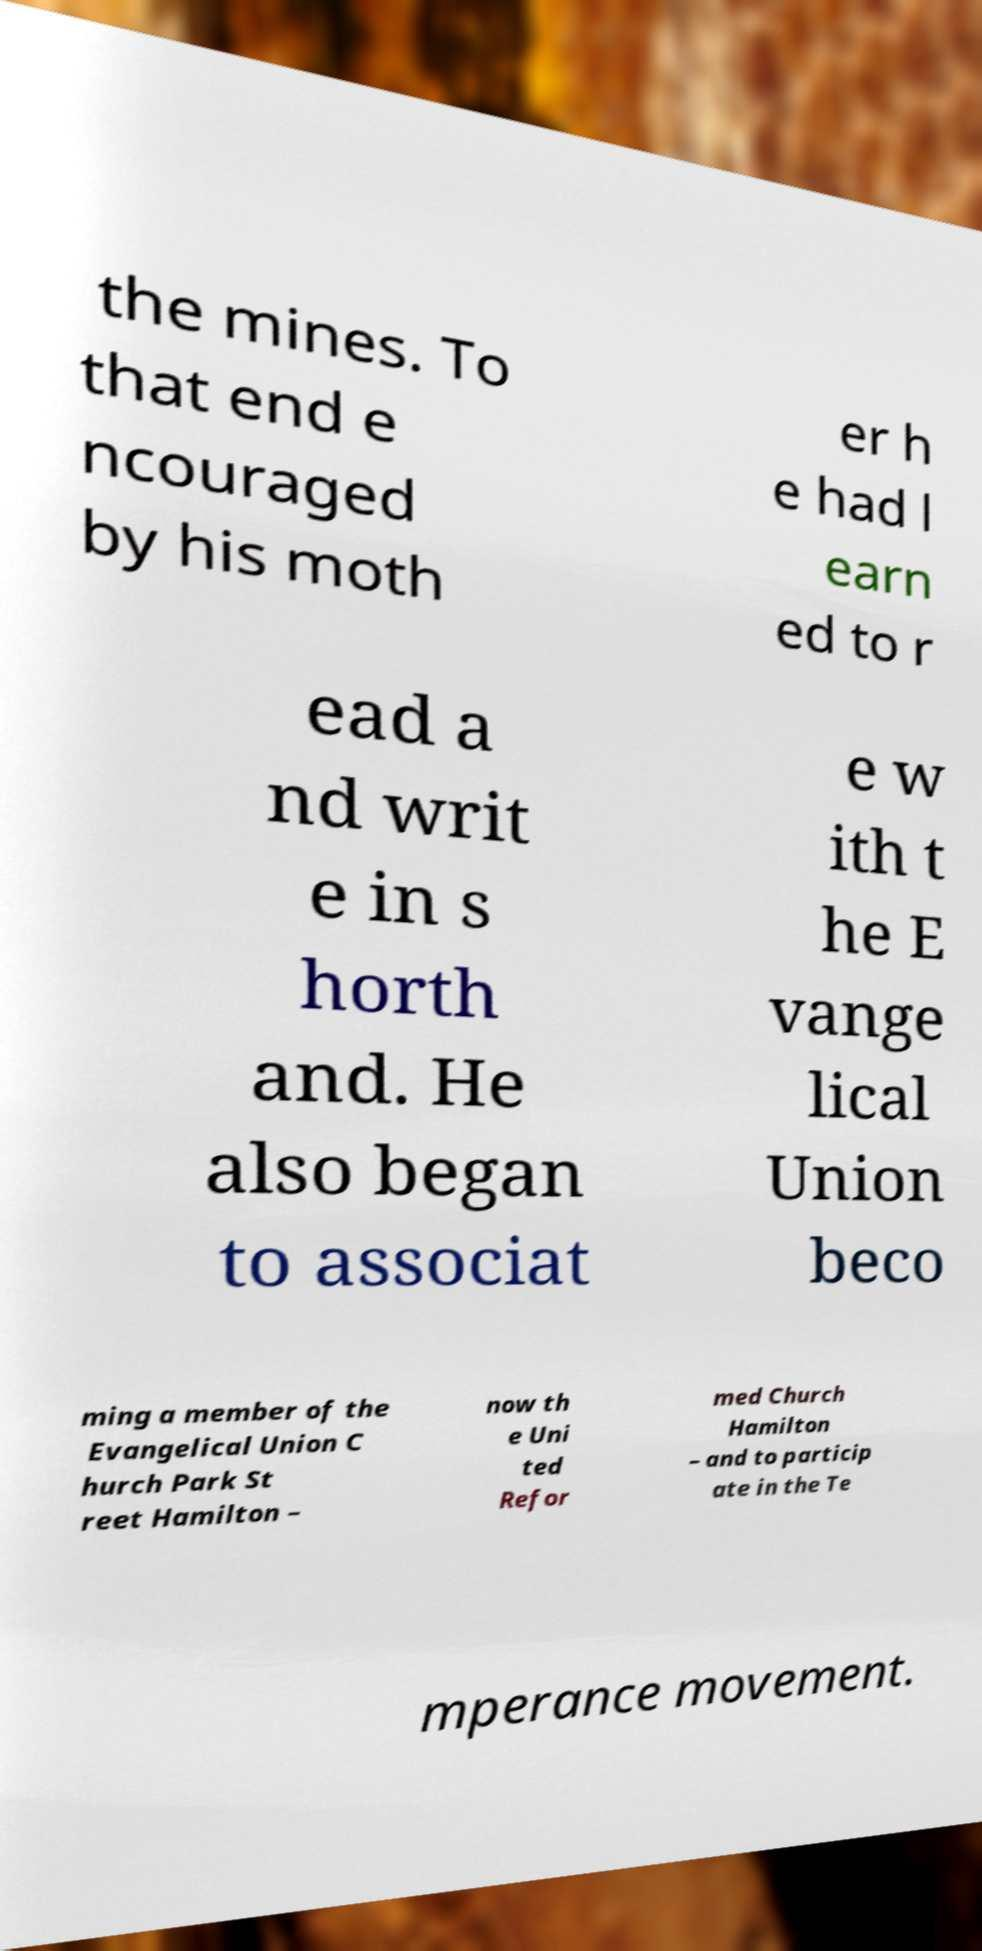Can you accurately transcribe the text from the provided image for me? the mines. To that end e ncouraged by his moth er h e had l earn ed to r ead a nd writ e in s horth and. He also began to associat e w ith t he E vange lical Union beco ming a member of the Evangelical Union C hurch Park St reet Hamilton – now th e Uni ted Refor med Church Hamilton – and to particip ate in the Te mperance movement. 